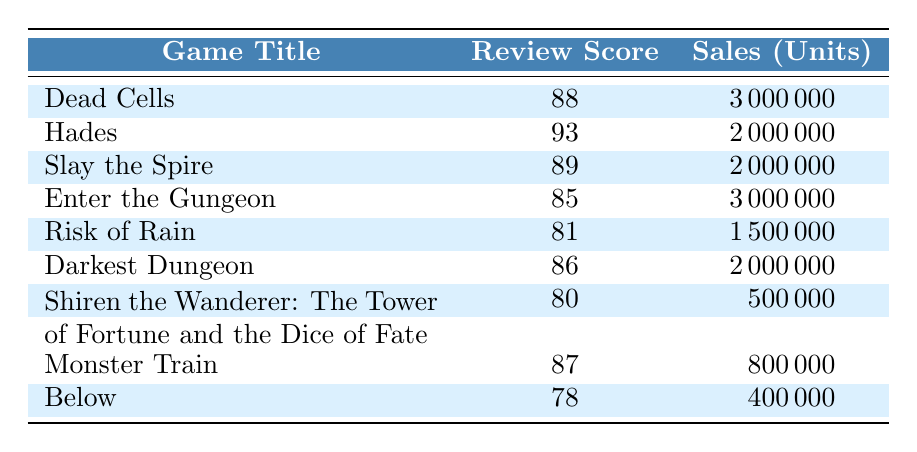What is the review score of "Hades"? The table shows the row for "Hades" which has a listed review score of 93.
Answer: 93 Which game has the highest sales units? Looking at the sales units column, "Dead Cells" and "Enter the Gungeon" both have 3000000 units, making them tied for the highest sales.
Answer: Dead Cells and Enter the Gungeon What is the average review score of the games listed? The review scores are 88, 93, 89, 85, 81, 86, 80, 87, and 78. Adding them gives 789. There are 9 games, so the average is 789/9 = 87.
Answer: 87 Is the review score of "Shiren the Wanderer: The Tower of Fortune and the Dice of Fate" higher than 85? Its review score is 80, which is less than 85. So, the statement is false.
Answer: No What is the difference in sales between "Risk of Rain" and "Monster Train"? "Risk of Rain" has 1500000 sales while "Monster Train" has 800000. The difference is 1500000 - 800000 = 700000.
Answer: 700000 How many games have a review score of 85 or higher? The games with scores of 85 or higher are: "Dead Cells," "Hades," "Slay the Spire," "Enter the Gungeon," "Darkest Dungeon," "Monster Train," and "Risk of Rain," totaling 7.
Answer: 7 What percentage of total sales does "Below" represent? The total sales units are 3000000 + 2000000 + 2000000 + 3000000 + 1500000 + 2000000 + 500000 + 800000 + 400000 = 11500000. "Below" has 400000 sales. So, (400000 / 11500000) * 100 ≈ 3.48%.
Answer: Approximately 3.48% Which game has a score closest to 82? The closest scores to 82 are "Risk of Rain" with 81 and "Darkest Dungeon" with 86, but 81 is the closest.
Answer: Risk of Rain Are there any games that have a review score of 78? Yes, the table indicates "Below" has a review score of 78.
Answer: Yes 